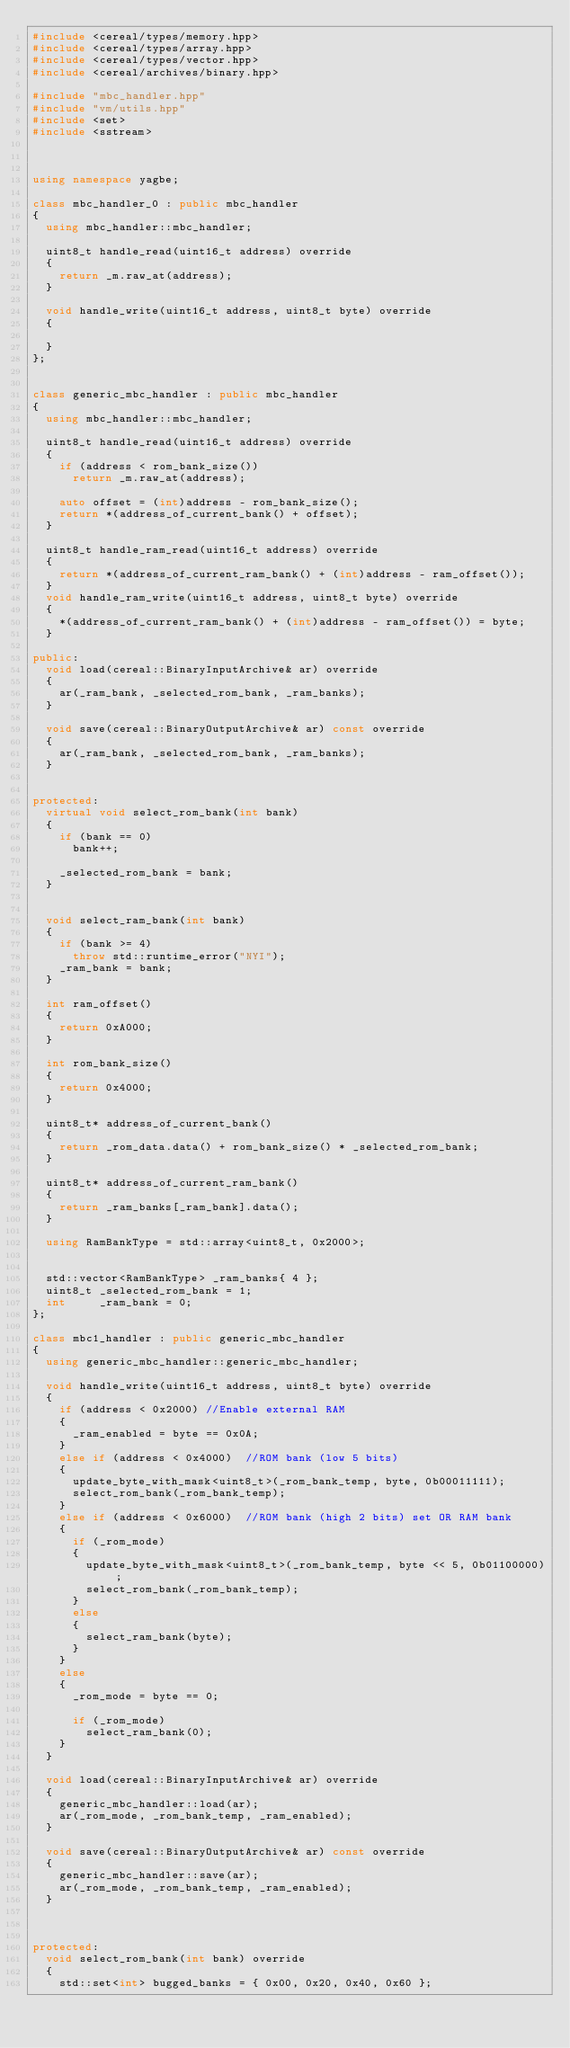Convert code to text. <code><loc_0><loc_0><loc_500><loc_500><_C++_>#include <cereal/types/memory.hpp>
#include <cereal/types/array.hpp>
#include <cereal/types/vector.hpp>
#include <cereal/archives/binary.hpp>

#include "mbc_handler.hpp"
#include "vm/utils.hpp"
#include <set>
#include <sstream>



using namespace yagbe;

class mbc_handler_0 : public mbc_handler
{
	using mbc_handler::mbc_handler;

	uint8_t handle_read(uint16_t address) override
	{
		return _m.raw_at(address);
	}

	void handle_write(uint16_t address, uint8_t byte) override
	{
		
	}
};


class generic_mbc_handler : public mbc_handler
{
	using mbc_handler::mbc_handler;

	uint8_t handle_read(uint16_t address) override
	{
		if (address < rom_bank_size())
			return _m.raw_at(address);

		auto offset = (int)address - rom_bank_size();
		return *(address_of_current_bank() + offset);
	}

	uint8_t handle_ram_read(uint16_t address) override
	{
		return *(address_of_current_ram_bank() + (int)address - ram_offset());
	}
	void handle_ram_write(uint16_t address, uint8_t byte) override
	{
		*(address_of_current_ram_bank() + (int)address - ram_offset()) = byte;
	}

public:
	void load(cereal::BinaryInputArchive& ar) override
	{
		ar(_ram_bank, _selected_rom_bank, _ram_banks);
	}

	void save(cereal::BinaryOutputArchive& ar) const override
	{
		ar(_ram_bank, _selected_rom_bank, _ram_banks);
	}


protected:
	virtual void select_rom_bank(int bank) 
	{
		if (bank == 0)
			bank++;

		_selected_rom_bank = bank;
	}


	void select_ram_bank(int bank)
	{
		if (bank >= 4)
			throw std::runtime_error("NYI");
		_ram_bank = bank;
	}

	int ram_offset()
	{
		return 0xA000;
	}

	int rom_bank_size()
	{
		return 0x4000;
	}

	uint8_t* address_of_current_bank()
	{
		return _rom_data.data() + rom_bank_size() * _selected_rom_bank;
	}

	uint8_t* address_of_current_ram_bank()
	{
		return _ram_banks[_ram_bank].data();
	}

	using RamBankType = std::array<uint8_t, 0x2000>;


	std::vector<RamBankType> _ram_banks{ 4 };
	uint8_t _selected_rom_bank = 1;
	int     _ram_bank = 0;
};

class mbc1_handler : public generic_mbc_handler
{
	using generic_mbc_handler::generic_mbc_handler;

	void handle_write(uint16_t address, uint8_t byte) override
	{
		if (address < 0x2000) //Enable external RAM
		{
			_ram_enabled = byte == 0x0A;
		}
		else if (address < 0x4000) 	//ROM bank (low 5 bits)
		{
			update_byte_with_mask<uint8_t>(_rom_bank_temp, byte, 0b00011111);
			select_rom_bank(_rom_bank_temp);
		}
		else if (address < 0x6000)	//ROM bank (high 2 bits) set OR RAM bank
		{
			if (_rom_mode)
			{
				update_byte_with_mask<uint8_t>(_rom_bank_temp, byte << 5, 0b01100000);
				select_rom_bank(_rom_bank_temp);
			}
			else
			{
				select_ram_bank(byte);
			}
		}
		else
		{
			_rom_mode = byte == 0;

			if (_rom_mode)
				select_ram_bank(0);
		}
	}

	void load(cereal::BinaryInputArchive& ar) override
	{
		generic_mbc_handler::load(ar);
		ar(_rom_mode, _rom_bank_temp, _ram_enabled);
	}

	void save(cereal::BinaryOutputArchive& ar) const override
	{
		generic_mbc_handler::save(ar);
		ar(_rom_mode, _rom_bank_temp, _ram_enabled);
	}



protected:
	void select_rom_bank(int bank) override
	{
		std::set<int> bugged_banks = { 0x00, 0x20, 0x40, 0x60 };</code> 